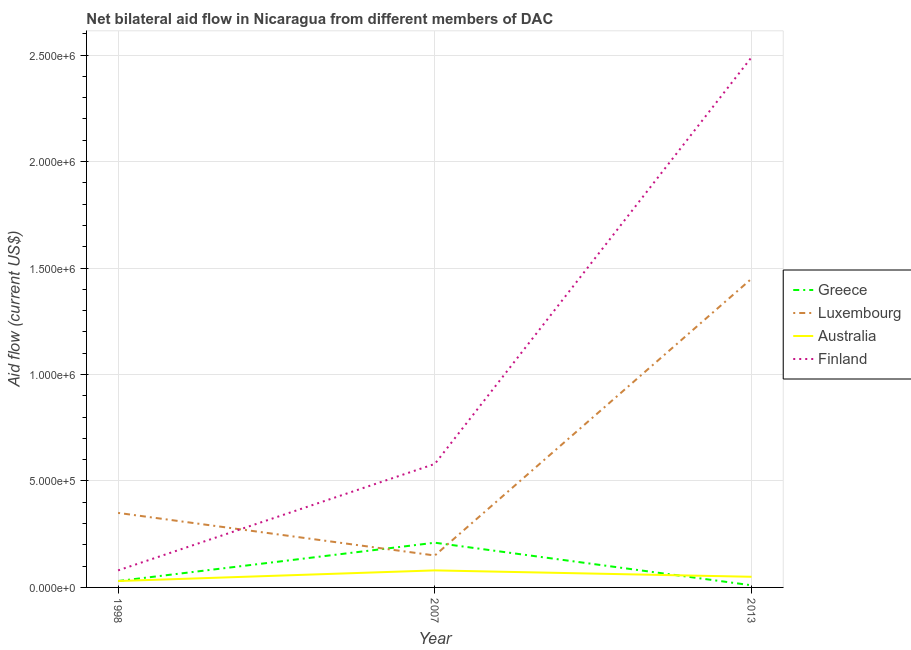How many different coloured lines are there?
Give a very brief answer. 4. What is the amount of aid given by australia in 2013?
Offer a very short reply. 5.00e+04. Across all years, what is the maximum amount of aid given by greece?
Ensure brevity in your answer.  2.10e+05. Across all years, what is the minimum amount of aid given by finland?
Provide a short and direct response. 8.00e+04. In which year was the amount of aid given by finland minimum?
Keep it short and to the point. 1998. What is the total amount of aid given by finland in the graph?
Ensure brevity in your answer.  3.15e+06. What is the difference between the amount of aid given by greece in 1998 and that in 2013?
Your response must be concise. 2.00e+04. What is the difference between the amount of aid given by australia in 1998 and the amount of aid given by luxembourg in 2013?
Offer a very short reply. -1.42e+06. What is the average amount of aid given by luxembourg per year?
Ensure brevity in your answer.  6.50e+05. In the year 2013, what is the difference between the amount of aid given by finland and amount of aid given by luxembourg?
Provide a succinct answer. 1.04e+06. What is the ratio of the amount of aid given by finland in 2007 to that in 2013?
Your answer should be compact. 0.23. What is the difference between the highest and the second highest amount of aid given by finland?
Ensure brevity in your answer.  1.91e+06. What is the difference between the highest and the lowest amount of aid given by finland?
Make the answer very short. 2.41e+06. Is it the case that in every year, the sum of the amount of aid given by luxembourg and amount of aid given by australia is greater than the sum of amount of aid given by greece and amount of aid given by finland?
Give a very brief answer. Yes. Is it the case that in every year, the sum of the amount of aid given by greece and amount of aid given by luxembourg is greater than the amount of aid given by australia?
Offer a very short reply. Yes. Does the amount of aid given by luxembourg monotonically increase over the years?
Provide a succinct answer. No. What is the difference between two consecutive major ticks on the Y-axis?
Provide a succinct answer. 5.00e+05. Does the graph contain any zero values?
Ensure brevity in your answer.  No. Does the graph contain grids?
Offer a terse response. Yes. Where does the legend appear in the graph?
Ensure brevity in your answer.  Center right. How many legend labels are there?
Your answer should be very brief. 4. How are the legend labels stacked?
Your response must be concise. Vertical. What is the title of the graph?
Make the answer very short. Net bilateral aid flow in Nicaragua from different members of DAC. What is the label or title of the X-axis?
Offer a terse response. Year. What is the label or title of the Y-axis?
Give a very brief answer. Aid flow (current US$). What is the Aid flow (current US$) of Greece in 1998?
Provide a short and direct response. 3.00e+04. What is the Aid flow (current US$) in Luxembourg in 2007?
Give a very brief answer. 1.50e+05. What is the Aid flow (current US$) of Australia in 2007?
Keep it short and to the point. 8.00e+04. What is the Aid flow (current US$) of Finland in 2007?
Your answer should be very brief. 5.80e+05. What is the Aid flow (current US$) of Greece in 2013?
Offer a very short reply. 10000. What is the Aid flow (current US$) in Luxembourg in 2013?
Provide a short and direct response. 1.45e+06. What is the Aid flow (current US$) in Finland in 2013?
Provide a succinct answer. 2.49e+06. Across all years, what is the maximum Aid flow (current US$) of Luxembourg?
Your answer should be very brief. 1.45e+06. Across all years, what is the maximum Aid flow (current US$) of Finland?
Your response must be concise. 2.49e+06. Across all years, what is the minimum Aid flow (current US$) in Greece?
Ensure brevity in your answer.  10000. Across all years, what is the minimum Aid flow (current US$) in Luxembourg?
Your answer should be very brief. 1.50e+05. Across all years, what is the minimum Aid flow (current US$) of Australia?
Your answer should be compact. 3.00e+04. What is the total Aid flow (current US$) in Luxembourg in the graph?
Provide a short and direct response. 1.95e+06. What is the total Aid flow (current US$) of Australia in the graph?
Your answer should be very brief. 1.60e+05. What is the total Aid flow (current US$) of Finland in the graph?
Provide a succinct answer. 3.15e+06. What is the difference between the Aid flow (current US$) of Australia in 1998 and that in 2007?
Give a very brief answer. -5.00e+04. What is the difference between the Aid flow (current US$) of Finland in 1998 and that in 2007?
Your response must be concise. -5.00e+05. What is the difference between the Aid flow (current US$) of Greece in 1998 and that in 2013?
Offer a very short reply. 2.00e+04. What is the difference between the Aid flow (current US$) in Luxembourg in 1998 and that in 2013?
Make the answer very short. -1.10e+06. What is the difference between the Aid flow (current US$) in Finland in 1998 and that in 2013?
Provide a short and direct response. -2.41e+06. What is the difference between the Aid flow (current US$) of Luxembourg in 2007 and that in 2013?
Offer a terse response. -1.30e+06. What is the difference between the Aid flow (current US$) of Finland in 2007 and that in 2013?
Ensure brevity in your answer.  -1.91e+06. What is the difference between the Aid flow (current US$) in Greece in 1998 and the Aid flow (current US$) in Australia in 2007?
Offer a very short reply. -5.00e+04. What is the difference between the Aid flow (current US$) in Greece in 1998 and the Aid flow (current US$) in Finland in 2007?
Provide a short and direct response. -5.50e+05. What is the difference between the Aid flow (current US$) of Luxembourg in 1998 and the Aid flow (current US$) of Australia in 2007?
Offer a very short reply. 2.70e+05. What is the difference between the Aid flow (current US$) in Australia in 1998 and the Aid flow (current US$) in Finland in 2007?
Your answer should be very brief. -5.50e+05. What is the difference between the Aid flow (current US$) of Greece in 1998 and the Aid flow (current US$) of Luxembourg in 2013?
Your answer should be very brief. -1.42e+06. What is the difference between the Aid flow (current US$) of Greece in 1998 and the Aid flow (current US$) of Finland in 2013?
Your answer should be compact. -2.46e+06. What is the difference between the Aid flow (current US$) in Luxembourg in 1998 and the Aid flow (current US$) in Australia in 2013?
Offer a terse response. 3.00e+05. What is the difference between the Aid flow (current US$) of Luxembourg in 1998 and the Aid flow (current US$) of Finland in 2013?
Ensure brevity in your answer.  -2.14e+06. What is the difference between the Aid flow (current US$) of Australia in 1998 and the Aid flow (current US$) of Finland in 2013?
Your answer should be compact. -2.46e+06. What is the difference between the Aid flow (current US$) in Greece in 2007 and the Aid flow (current US$) in Luxembourg in 2013?
Provide a short and direct response. -1.24e+06. What is the difference between the Aid flow (current US$) of Greece in 2007 and the Aid flow (current US$) of Australia in 2013?
Offer a terse response. 1.60e+05. What is the difference between the Aid flow (current US$) of Greece in 2007 and the Aid flow (current US$) of Finland in 2013?
Provide a succinct answer. -2.28e+06. What is the difference between the Aid flow (current US$) of Luxembourg in 2007 and the Aid flow (current US$) of Finland in 2013?
Keep it short and to the point. -2.34e+06. What is the difference between the Aid flow (current US$) in Australia in 2007 and the Aid flow (current US$) in Finland in 2013?
Your answer should be compact. -2.41e+06. What is the average Aid flow (current US$) in Greece per year?
Keep it short and to the point. 8.33e+04. What is the average Aid flow (current US$) in Luxembourg per year?
Give a very brief answer. 6.50e+05. What is the average Aid flow (current US$) in Australia per year?
Make the answer very short. 5.33e+04. What is the average Aid flow (current US$) of Finland per year?
Offer a terse response. 1.05e+06. In the year 1998, what is the difference between the Aid flow (current US$) of Greece and Aid flow (current US$) of Luxembourg?
Your response must be concise. -3.20e+05. In the year 1998, what is the difference between the Aid flow (current US$) of Luxembourg and Aid flow (current US$) of Australia?
Your response must be concise. 3.20e+05. In the year 1998, what is the difference between the Aid flow (current US$) of Luxembourg and Aid flow (current US$) of Finland?
Your answer should be very brief. 2.70e+05. In the year 2007, what is the difference between the Aid flow (current US$) in Greece and Aid flow (current US$) in Australia?
Provide a succinct answer. 1.30e+05. In the year 2007, what is the difference between the Aid flow (current US$) of Greece and Aid flow (current US$) of Finland?
Make the answer very short. -3.70e+05. In the year 2007, what is the difference between the Aid flow (current US$) in Luxembourg and Aid flow (current US$) in Finland?
Provide a short and direct response. -4.30e+05. In the year 2007, what is the difference between the Aid flow (current US$) of Australia and Aid flow (current US$) of Finland?
Your response must be concise. -5.00e+05. In the year 2013, what is the difference between the Aid flow (current US$) in Greece and Aid flow (current US$) in Luxembourg?
Provide a short and direct response. -1.44e+06. In the year 2013, what is the difference between the Aid flow (current US$) in Greece and Aid flow (current US$) in Australia?
Give a very brief answer. -4.00e+04. In the year 2013, what is the difference between the Aid flow (current US$) of Greece and Aid flow (current US$) of Finland?
Make the answer very short. -2.48e+06. In the year 2013, what is the difference between the Aid flow (current US$) of Luxembourg and Aid flow (current US$) of Australia?
Provide a succinct answer. 1.40e+06. In the year 2013, what is the difference between the Aid flow (current US$) in Luxembourg and Aid flow (current US$) in Finland?
Make the answer very short. -1.04e+06. In the year 2013, what is the difference between the Aid flow (current US$) of Australia and Aid flow (current US$) of Finland?
Your response must be concise. -2.44e+06. What is the ratio of the Aid flow (current US$) in Greece in 1998 to that in 2007?
Ensure brevity in your answer.  0.14. What is the ratio of the Aid flow (current US$) in Luxembourg in 1998 to that in 2007?
Provide a short and direct response. 2.33. What is the ratio of the Aid flow (current US$) of Finland in 1998 to that in 2007?
Provide a short and direct response. 0.14. What is the ratio of the Aid flow (current US$) in Luxembourg in 1998 to that in 2013?
Ensure brevity in your answer.  0.24. What is the ratio of the Aid flow (current US$) in Australia in 1998 to that in 2013?
Your response must be concise. 0.6. What is the ratio of the Aid flow (current US$) in Finland in 1998 to that in 2013?
Your answer should be very brief. 0.03. What is the ratio of the Aid flow (current US$) of Luxembourg in 2007 to that in 2013?
Provide a succinct answer. 0.1. What is the ratio of the Aid flow (current US$) of Australia in 2007 to that in 2013?
Give a very brief answer. 1.6. What is the ratio of the Aid flow (current US$) of Finland in 2007 to that in 2013?
Your answer should be very brief. 0.23. What is the difference between the highest and the second highest Aid flow (current US$) of Greece?
Make the answer very short. 1.80e+05. What is the difference between the highest and the second highest Aid flow (current US$) of Luxembourg?
Keep it short and to the point. 1.10e+06. What is the difference between the highest and the second highest Aid flow (current US$) of Finland?
Keep it short and to the point. 1.91e+06. What is the difference between the highest and the lowest Aid flow (current US$) of Greece?
Offer a terse response. 2.00e+05. What is the difference between the highest and the lowest Aid flow (current US$) in Luxembourg?
Provide a succinct answer. 1.30e+06. What is the difference between the highest and the lowest Aid flow (current US$) of Finland?
Your response must be concise. 2.41e+06. 